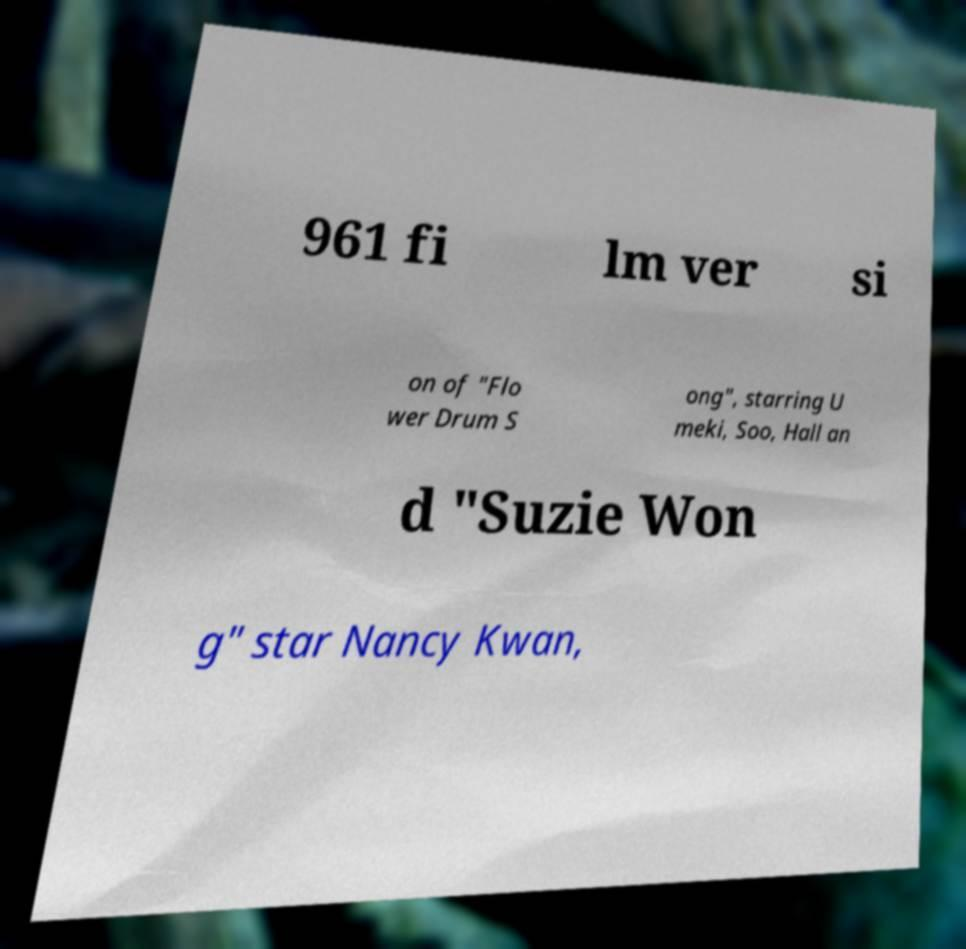Could you extract and type out the text from this image? 961 fi lm ver si on of "Flo wer Drum S ong", starring U meki, Soo, Hall an d "Suzie Won g" star Nancy Kwan, 